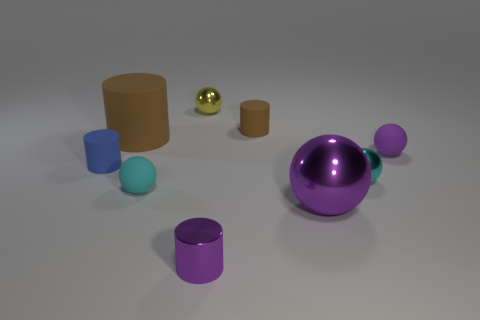Do the big metal sphere and the shiny cylinder have the same color?
Provide a short and direct response. Yes. What is the shape of the brown object left of the yellow metallic object that is behind the small cyan matte object?
Your response must be concise. Cylinder. What number of tiny things are cylinders or purple things?
Your answer should be compact. 4. What number of other large brown things are the same shape as the large brown object?
Offer a terse response. 0. There is a tiny purple shiny thing; is its shape the same as the shiny object that is right of the big purple metal thing?
Provide a succinct answer. No. There is a small purple matte object; how many small rubber spheres are in front of it?
Your response must be concise. 1. Is there a thing that has the same size as the blue matte cylinder?
Provide a short and direct response. Yes. There is a purple object that is to the left of the small brown thing; is its shape the same as the big purple object?
Offer a very short reply. No. The big shiny object has what color?
Offer a terse response. Purple. The rubber thing that is the same color as the big matte cylinder is what shape?
Ensure brevity in your answer.  Cylinder. 